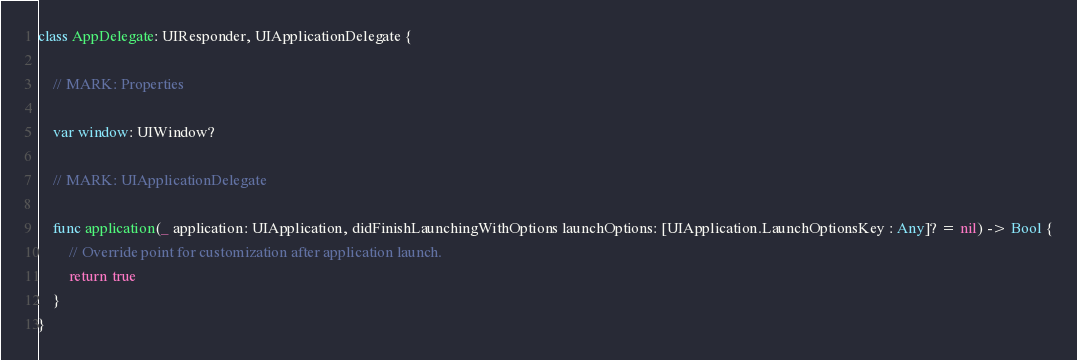Convert code to text. <code><loc_0><loc_0><loc_500><loc_500><_Swift_>class AppDelegate: UIResponder, UIApplicationDelegate {
    
    // MARK: Properties
    
    var window: UIWindow?
    
    // MARK: UIApplicationDelegate
    
    func application(_ application: UIApplication, didFinishLaunchingWithOptions launchOptions: [UIApplication.LaunchOptionsKey : Any]? = nil) -> Bool {
        // Override point for customization after application launch.
        return true
    }
}
</code> 